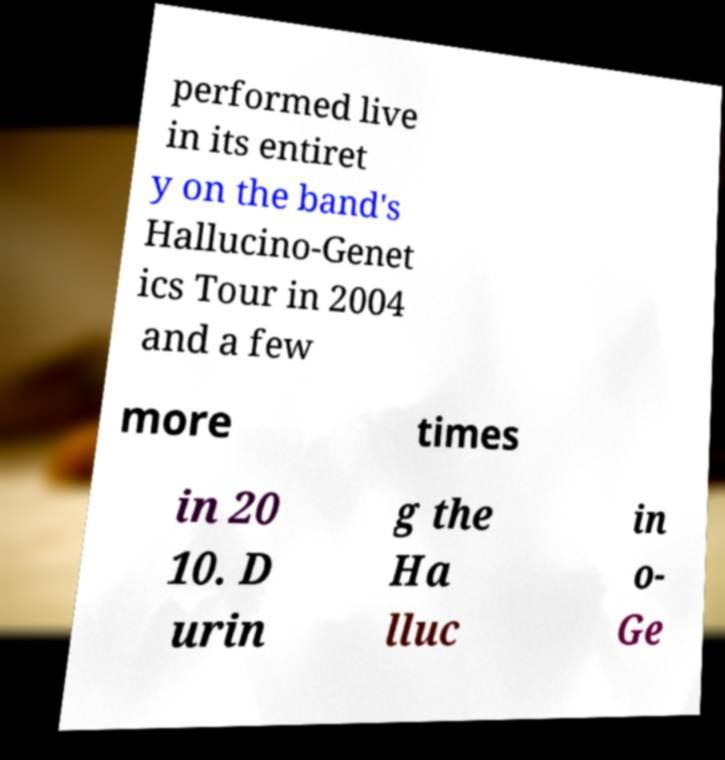Please identify and transcribe the text found in this image. performed live in its entiret y on the band's Hallucino-Genet ics Tour in 2004 and a few more times in 20 10. D urin g the Ha lluc in o- Ge 